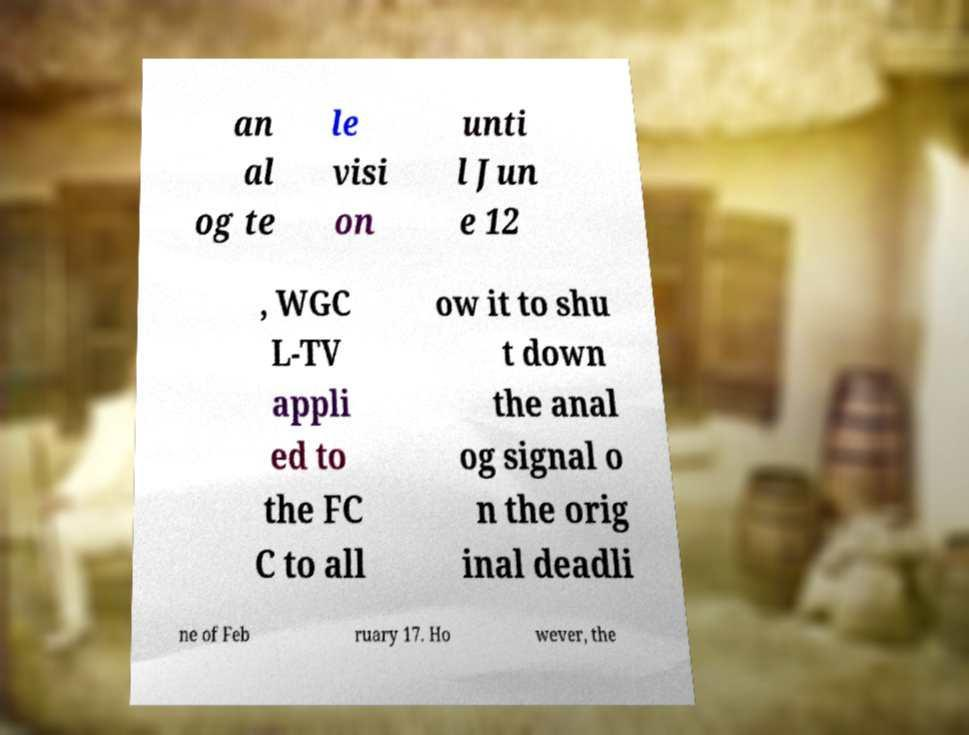What messages or text are displayed in this image? I need them in a readable, typed format. an al og te le visi on unti l Jun e 12 , WGC L-TV appli ed to the FC C to all ow it to shu t down the anal og signal o n the orig inal deadli ne of Feb ruary 17. Ho wever, the 